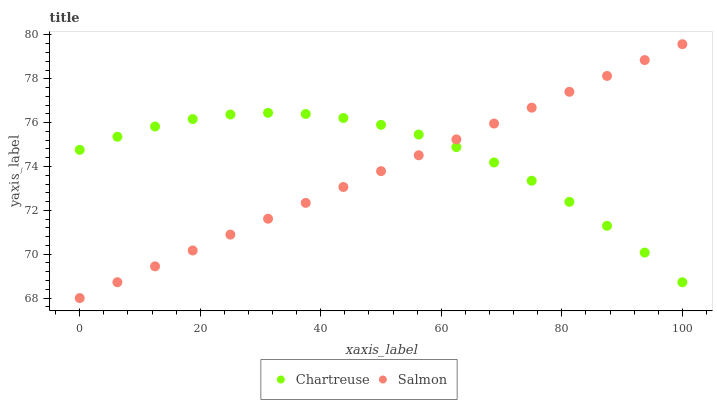Does Salmon have the minimum area under the curve?
Answer yes or no. Yes. Does Chartreuse have the maximum area under the curve?
Answer yes or no. Yes. Does Salmon have the maximum area under the curve?
Answer yes or no. No. Is Salmon the smoothest?
Answer yes or no. Yes. Is Chartreuse the roughest?
Answer yes or no. Yes. Is Salmon the roughest?
Answer yes or no. No. Does Salmon have the lowest value?
Answer yes or no. Yes. Does Salmon have the highest value?
Answer yes or no. Yes. Does Salmon intersect Chartreuse?
Answer yes or no. Yes. Is Salmon less than Chartreuse?
Answer yes or no. No. Is Salmon greater than Chartreuse?
Answer yes or no. No. 